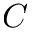<formula> <loc_0><loc_0><loc_500><loc_500>C</formula> 